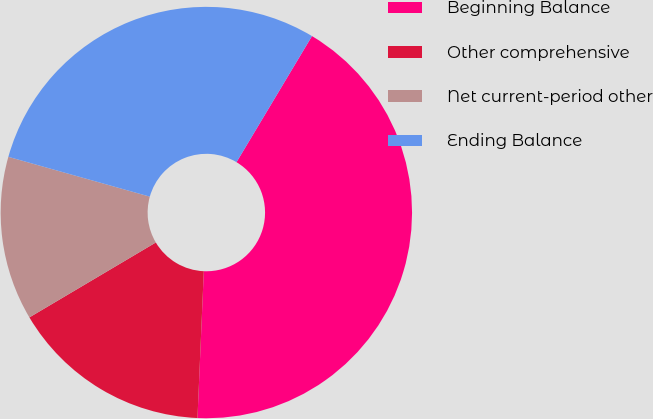Convert chart. <chart><loc_0><loc_0><loc_500><loc_500><pie_chart><fcel>Beginning Balance<fcel>Other comprehensive<fcel>Net current-period other<fcel>Ending Balance<nl><fcel>42.1%<fcel>15.8%<fcel>12.88%<fcel>29.22%<nl></chart> 